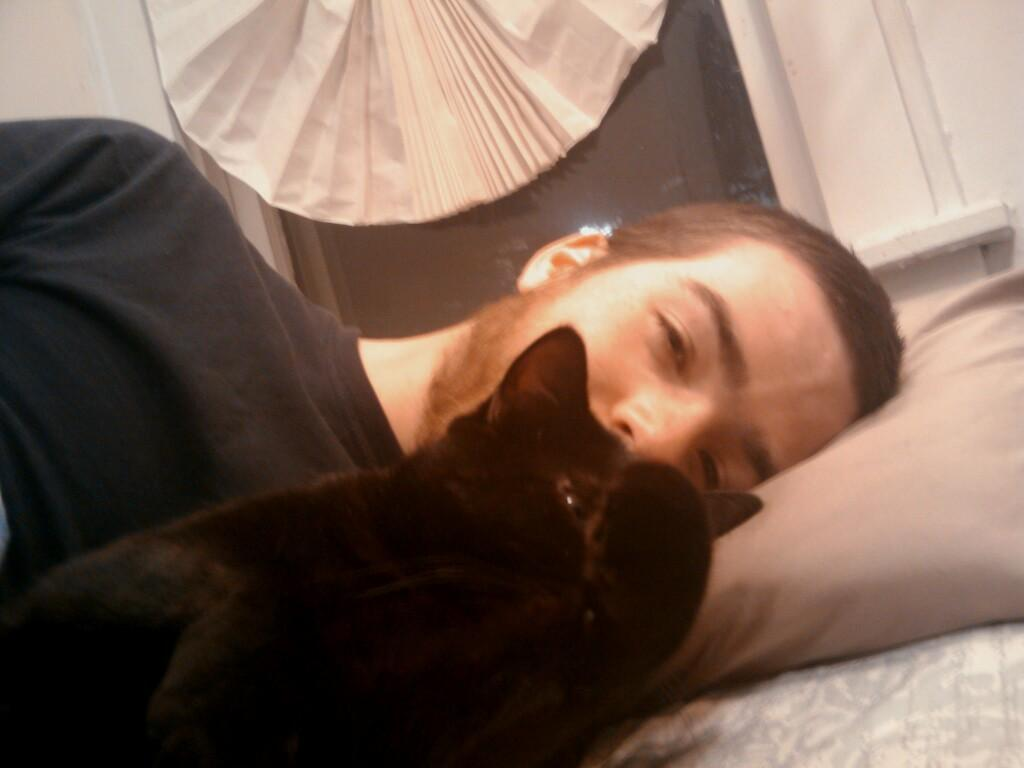What type of animal is in the image? There is a cat in the image. Can you describe the cat's appearance? The cat is black. What is happening in the background of the image? There is a person laying on a bed in the background. What is the person wearing? The person is wearing a black shirt. What color is the wall in the background? The wall in the background is white. What type of cracker is the cat holding in the image? There is no cracker present in the image; it features a black cat and a person laying on a bed in the background. What direction is the beam of light coming from in the image? There is no beam of light present in the image. 